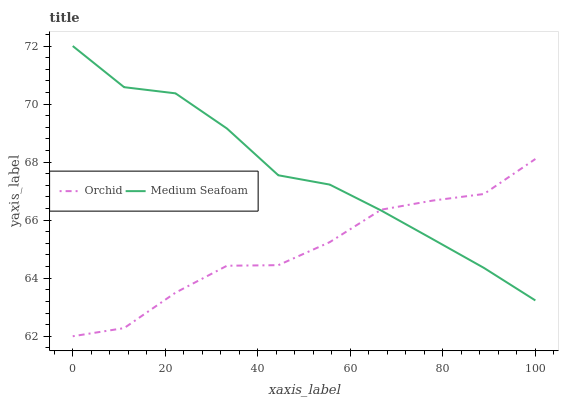Does Orchid have the minimum area under the curve?
Answer yes or no. Yes. Does Medium Seafoam have the maximum area under the curve?
Answer yes or no. Yes. Does Orchid have the maximum area under the curve?
Answer yes or no. No. Is Medium Seafoam the smoothest?
Answer yes or no. Yes. Is Orchid the roughest?
Answer yes or no. Yes. Is Orchid the smoothest?
Answer yes or no. No. Does Orchid have the lowest value?
Answer yes or no. Yes. Does Medium Seafoam have the highest value?
Answer yes or no. Yes. Does Orchid have the highest value?
Answer yes or no. No. Does Medium Seafoam intersect Orchid?
Answer yes or no. Yes. Is Medium Seafoam less than Orchid?
Answer yes or no. No. Is Medium Seafoam greater than Orchid?
Answer yes or no. No. 